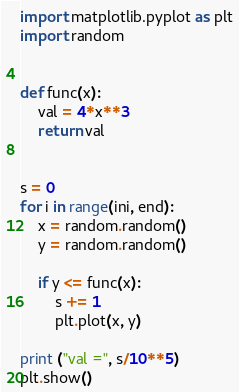<code> <loc_0><loc_0><loc_500><loc_500><_Python_>import matplotlib.pyplot as plt
import random


def func(x):
	val = 4*x**3
	return val


s = 0
for i in range(ini, end):
	x = random.random()
	y = random.random()

	if y <= func(x):
		s += 1
		plt.plot(x, y)

print ("val =", s/10**5)
plt.show()
</code> 